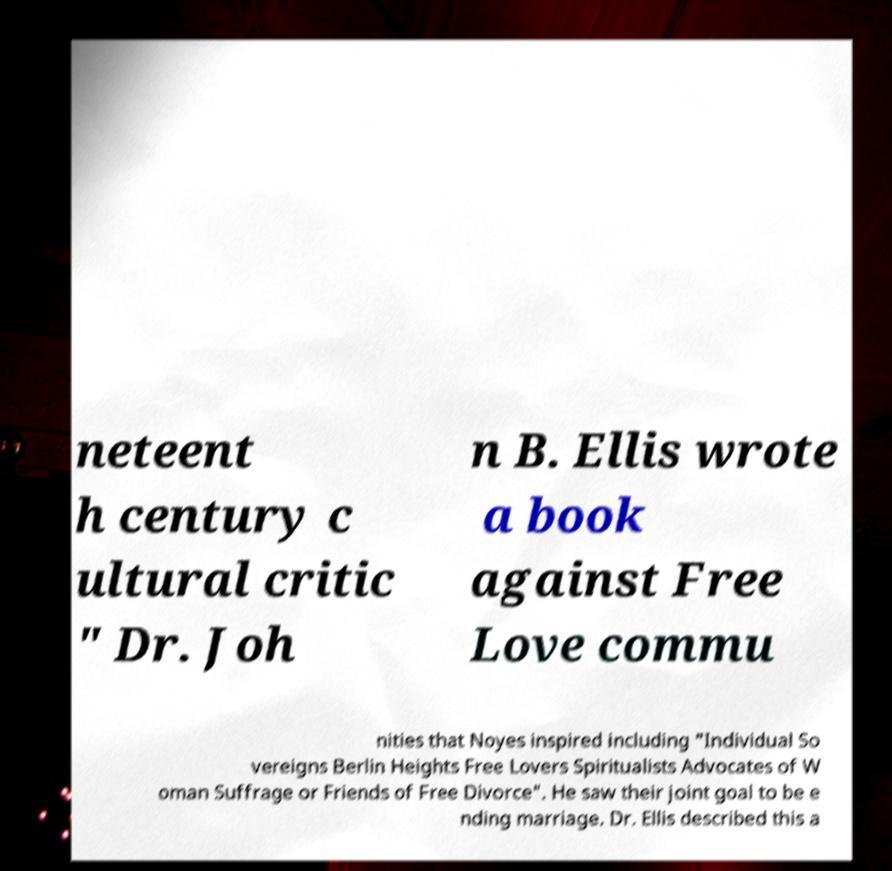For documentation purposes, I need the text within this image transcribed. Could you provide that? neteent h century c ultural critic " Dr. Joh n B. Ellis wrote a book against Free Love commu nities that Noyes inspired including "Individual So vereigns Berlin Heights Free Lovers Spiritualists Advocates of W oman Suffrage or Friends of Free Divorce". He saw their joint goal to be e nding marriage. Dr. Ellis described this a 